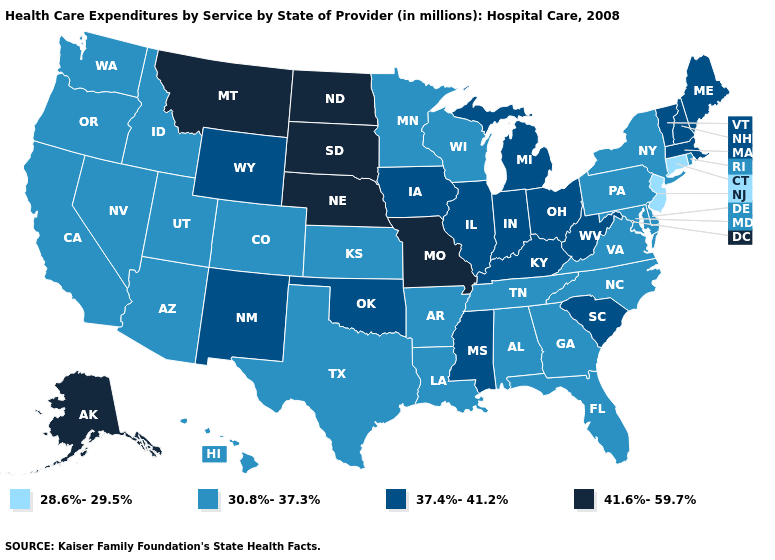Which states have the lowest value in the West?
Short answer required. Arizona, California, Colorado, Hawaii, Idaho, Nevada, Oregon, Utah, Washington. Name the states that have a value in the range 37.4%-41.2%?
Give a very brief answer. Illinois, Indiana, Iowa, Kentucky, Maine, Massachusetts, Michigan, Mississippi, New Hampshire, New Mexico, Ohio, Oklahoma, South Carolina, Vermont, West Virginia, Wyoming. Name the states that have a value in the range 41.6%-59.7%?
Quick response, please. Alaska, Missouri, Montana, Nebraska, North Dakota, South Dakota. Which states have the lowest value in the USA?
Short answer required. Connecticut, New Jersey. Name the states that have a value in the range 41.6%-59.7%?
Answer briefly. Alaska, Missouri, Montana, Nebraska, North Dakota, South Dakota. Does the first symbol in the legend represent the smallest category?
Give a very brief answer. Yes. What is the value of New York?
Short answer required. 30.8%-37.3%. What is the lowest value in the USA?
Keep it brief. 28.6%-29.5%. Name the states that have a value in the range 30.8%-37.3%?
Be succinct. Alabama, Arizona, Arkansas, California, Colorado, Delaware, Florida, Georgia, Hawaii, Idaho, Kansas, Louisiana, Maryland, Minnesota, Nevada, New York, North Carolina, Oregon, Pennsylvania, Rhode Island, Tennessee, Texas, Utah, Virginia, Washington, Wisconsin. What is the value of North Dakota?
Keep it brief. 41.6%-59.7%. Does Mississippi have the highest value in the South?
Give a very brief answer. Yes. What is the lowest value in states that border West Virginia?
Concise answer only. 30.8%-37.3%. Which states have the lowest value in the USA?
Write a very short answer. Connecticut, New Jersey. Does Pennsylvania have the highest value in the USA?
Write a very short answer. No. 